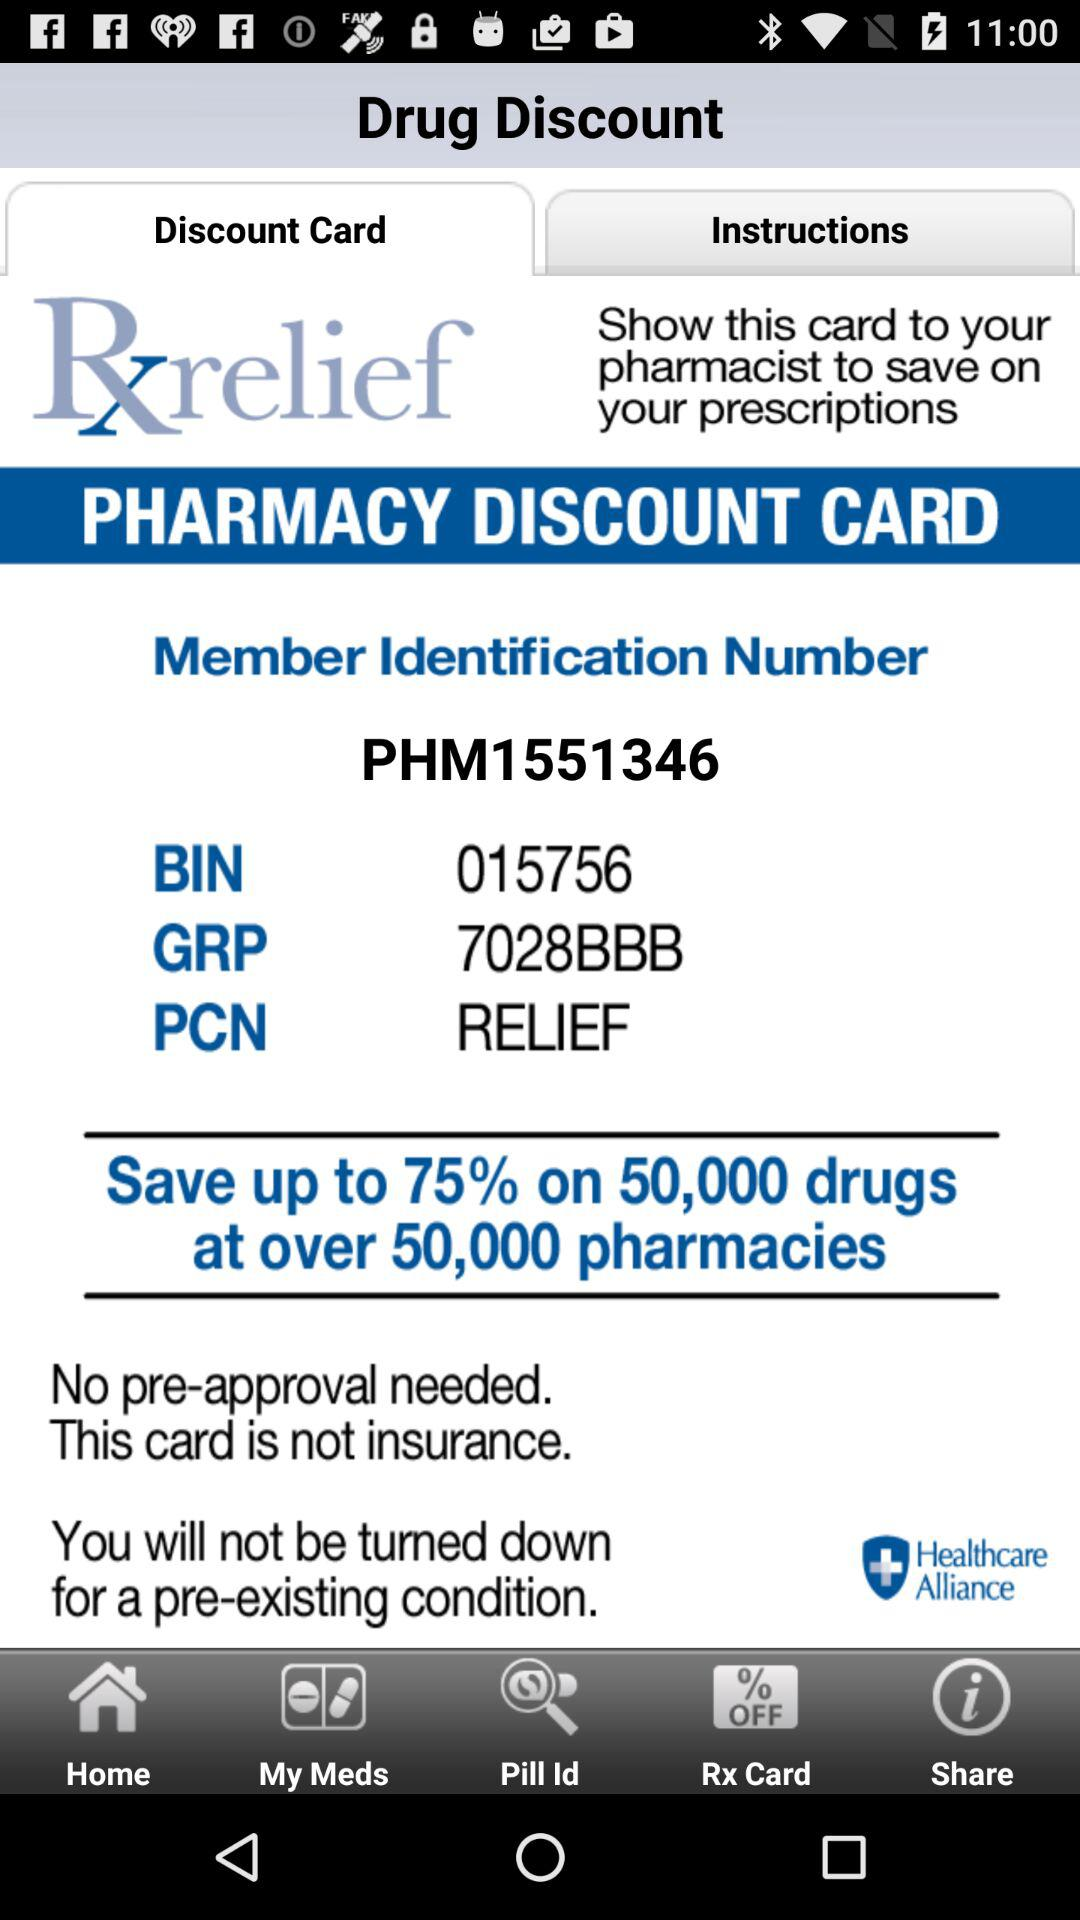What is the BIN number? The BIN number is 015756. 